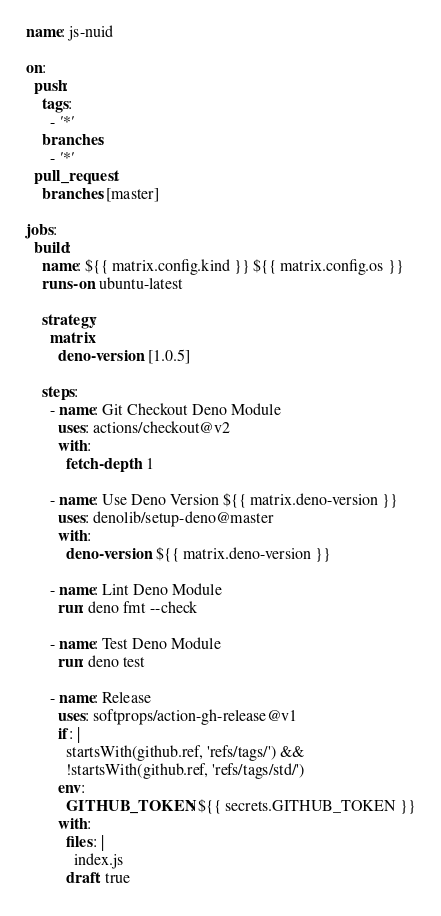<code> <loc_0><loc_0><loc_500><loc_500><_YAML_>name: js-nuid

on:
  push:
    tags:
      - '*'
    branches:
      - '*'
  pull_request:
    branches: [master]

jobs:
  build:
    name: ${{ matrix.config.kind }} ${{ matrix.config.os }}
    runs-on: ubuntu-latest

    strategy:
      matrix:
        deno-version: [1.0.5]

    steps:
      - name: Git Checkout Deno Module
        uses: actions/checkout@v2
        with:
          fetch-depth: 1

      - name: Use Deno Version ${{ matrix.deno-version }}
        uses: denolib/setup-deno@master
        with:
          deno-version: ${{ matrix.deno-version }}

      - name: Lint Deno Module
        run: deno fmt --check

      - name: Test Deno Module
        run: deno test

      - name: Release
        uses: softprops/action-gh-release@v1
        if: |
          startsWith(github.ref, 'refs/tags/') &&
          !startsWith(github.ref, 'refs/tags/std/')
        env:
          GITHUB_TOKEN: ${{ secrets.GITHUB_TOKEN }}
        with:
          files: |
            index.js
          draft: true
</code> 